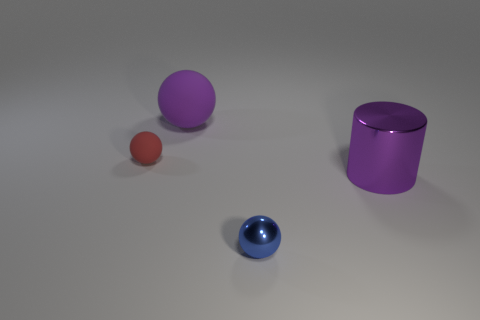How many objects are matte balls to the left of the big ball or tiny objects in front of the large cylinder?
Make the answer very short. 2. Is the material of the purple cylinder right of the red rubber ball the same as the purple object that is left of the tiny metal sphere?
Keep it short and to the point. No. What shape is the large purple thing left of the tiny sphere that is in front of the tiny red ball?
Provide a short and direct response. Sphere. Are there any other things that have the same color as the big metal thing?
Your answer should be compact. Yes. Are there any red matte objects that are on the right side of the object that is on the left side of the purple thing that is on the left side of the blue shiny thing?
Make the answer very short. No. Do the tiny thing in front of the tiny matte object and the big thing that is behind the big purple cylinder have the same color?
Offer a terse response. No. What is the material of the red sphere that is the same size as the blue object?
Your answer should be compact. Rubber. There is a rubber object that is in front of the purple object left of the purple thing in front of the tiny rubber thing; what size is it?
Your answer should be very brief. Small. What number of other things are there of the same material as the tiny red thing
Provide a short and direct response. 1. There is a red sphere behind the big purple metal object; what size is it?
Give a very brief answer. Small. 